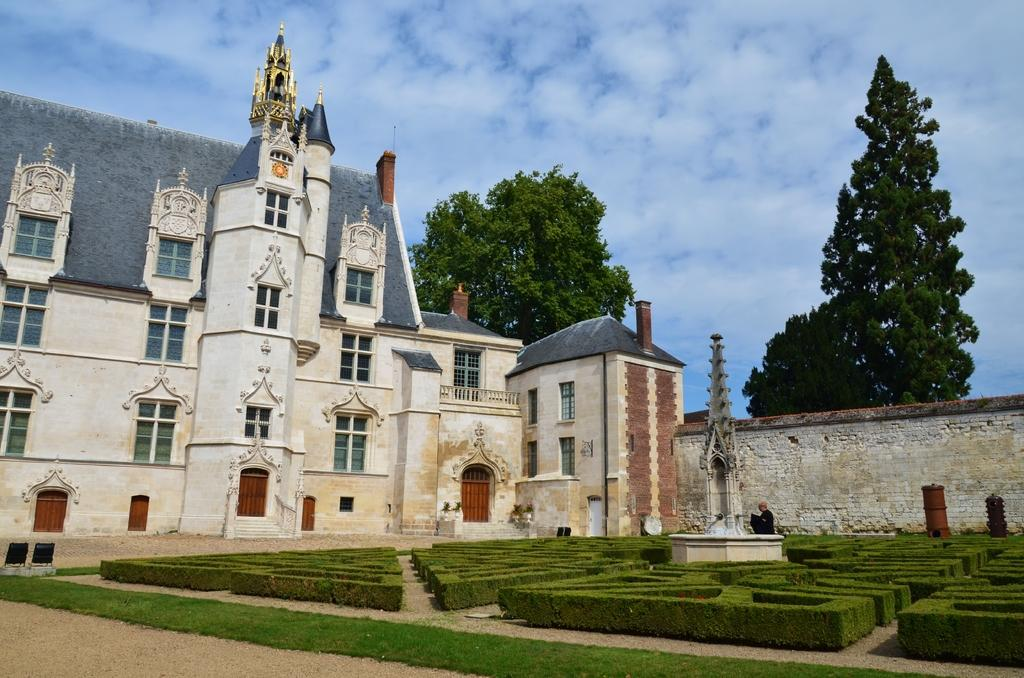What type of structure is present in the image? There is a building in the image. What is located near the building? There is a wall in the image, and bushes are visible in front of the wall. Can you describe the person in the image? There is a person in front of the wall. What is visible at the top of the image? The sky is visible at the top of the image. What type of vegetation is present in the image? There are trees in the image. How many frogs are sitting on the knife in the image? There are no frogs or knives present in the image. Is the rain affecting the visibility of the trees in the image? There is no mention of rain in the image, and the visibility of the trees is not affected by any rain. 